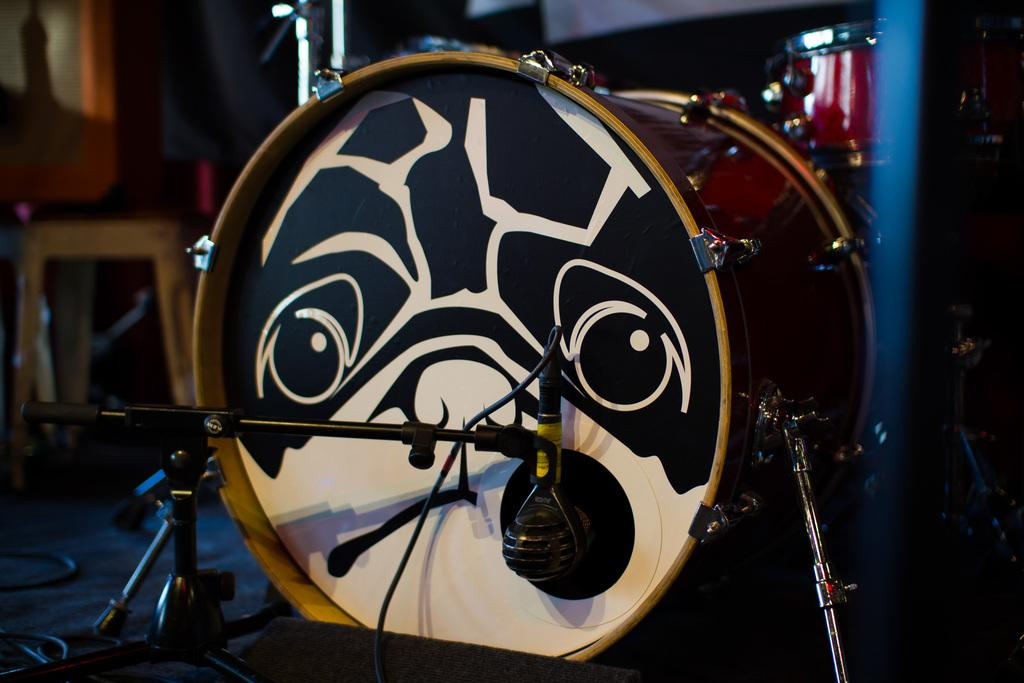What musical instruments are present in the image? There are drums in the image. What equipment is used for amplifying sound in the image? There is a microphone in the image. What are the stands used for in the image? The stands are used to hold the drums and microphone in the image. Can you describe the background of the image? The background of the image is blurry. What piece of furniture can be seen in the background of the image? There is a chair in the background of the image. What type of government is depicted in the image? There is no depiction of a government in the image; it features musical instruments and equipment. Can you tell me how many turkeys are present in the image? There are no turkeys present in the image; it features drums, a microphone, stands, and a chair. 